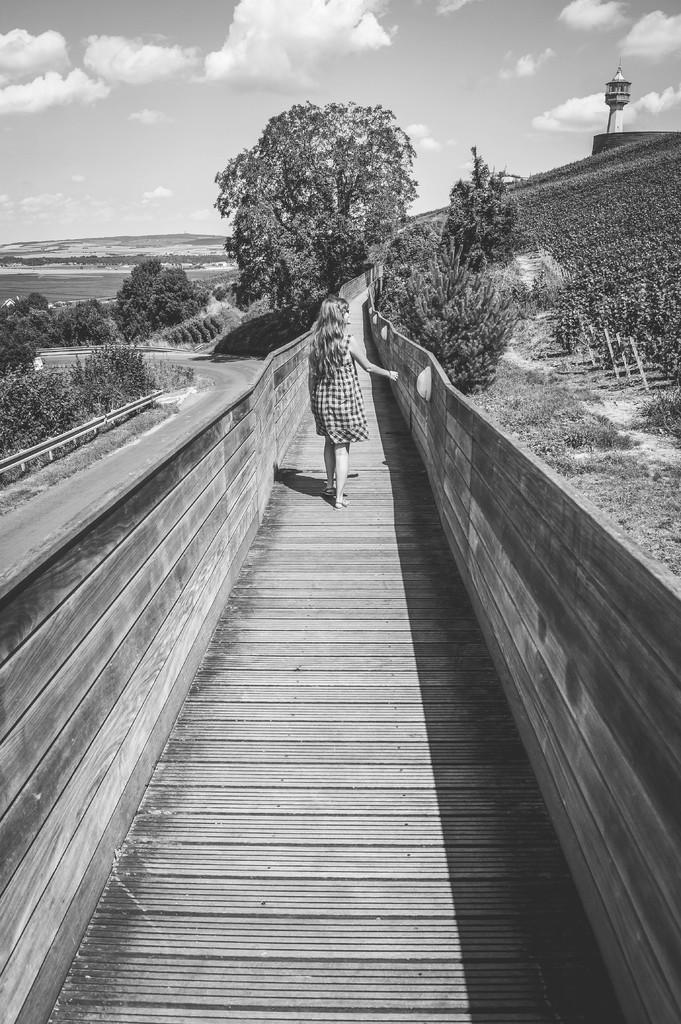How would you summarize this image in a sentence or two? In this picture there is a girl walking. At the back there are trees and there is a mountain. On the right side of the image there is a tower and there is a fence. On the left side of the image there is a road and there is a railing. At the top there is sky and there are clouds. At the bottom there plants and there is grass. 